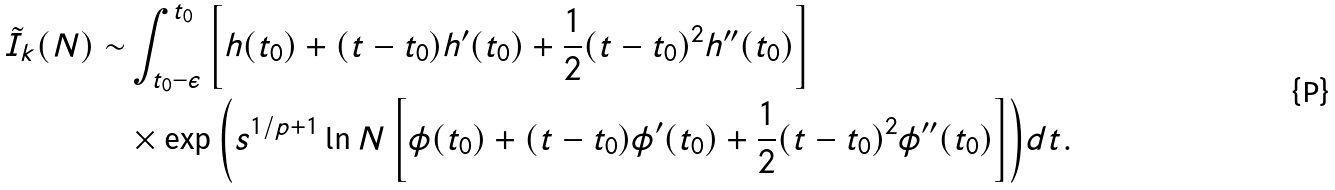Convert formula to latex. <formula><loc_0><loc_0><loc_500><loc_500>\tilde { I } _ { k } ( N ) \sim & \int _ { t _ { 0 } - \epsilon } ^ { t _ { 0 } } \left [ h ( t _ { 0 } ) + ( t - t _ { 0 } ) h ^ { \prime } ( t _ { 0 } ) + \frac { 1 } { 2 } ( t - t _ { 0 } ) ^ { 2 } h ^ { \prime \prime } ( t _ { 0 } ) \right ] \\ & \times \exp { \left ( s ^ { 1 / p + 1 } \ln N \left [ \phi ( t _ { 0 } ) + ( t - t _ { 0 } ) \phi ^ { \prime } ( t _ { 0 } ) + \frac { 1 } { 2 } ( t - t _ { 0 } ) ^ { 2 } \phi ^ { \prime \prime } ( t _ { 0 } ) \right ] \right ) } d t .</formula> 